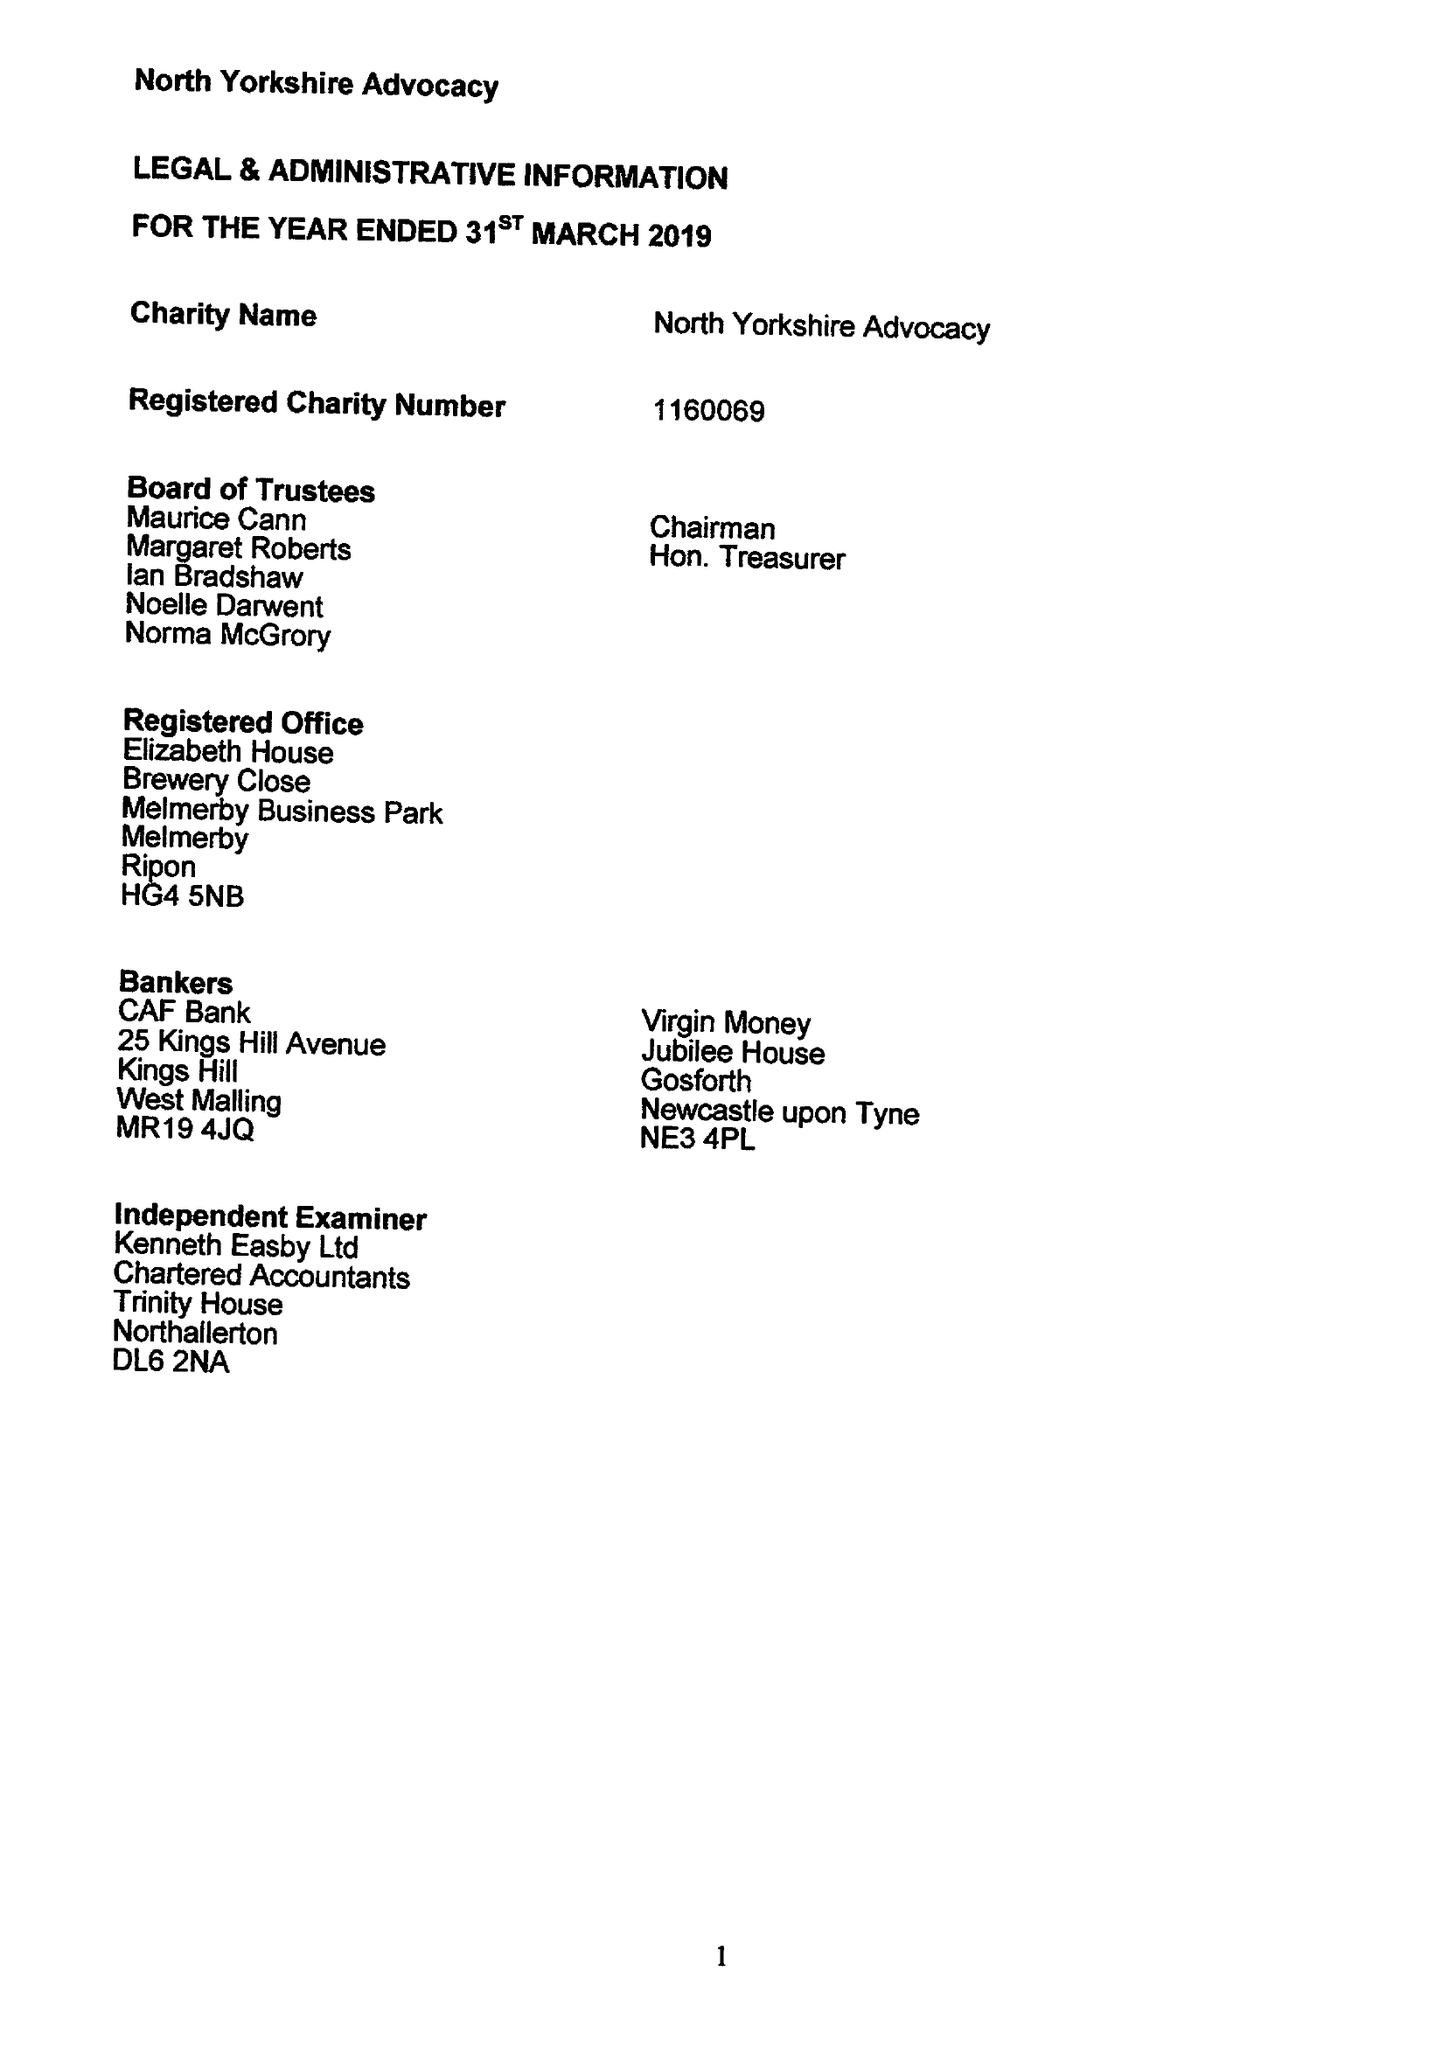What is the value for the report_date?
Answer the question using a single word or phrase. 2018-03-30 